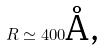<formula> <loc_0><loc_0><loc_500><loc_500>R \simeq 4 0 0 \text {\AA ,}</formula> 